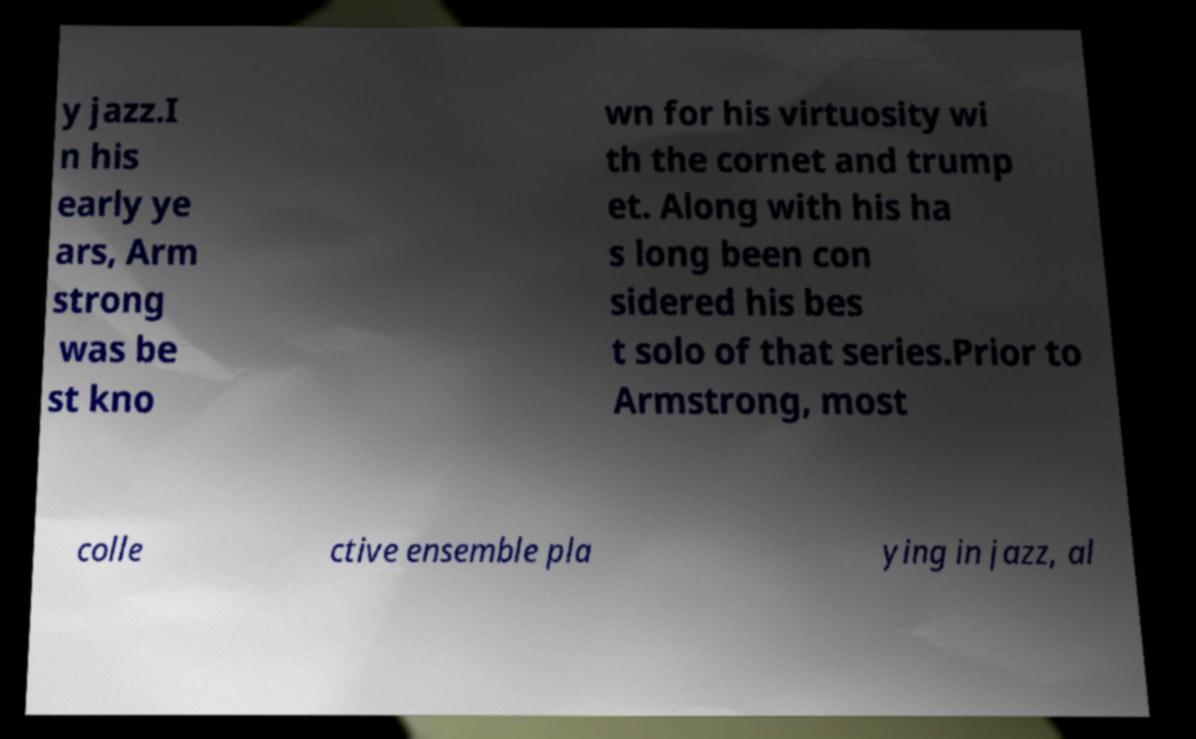There's text embedded in this image that I need extracted. Can you transcribe it verbatim? y jazz.I n his early ye ars, Arm strong was be st kno wn for his virtuosity wi th the cornet and trump et. Along with his ha s long been con sidered his bes t solo of that series.Prior to Armstrong, most colle ctive ensemble pla ying in jazz, al 